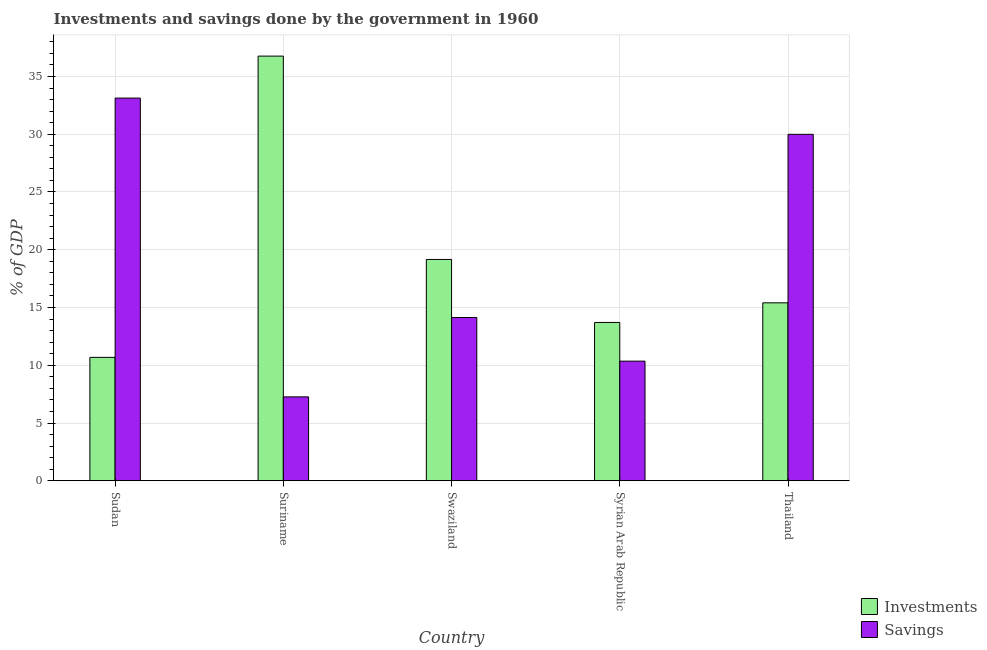How many groups of bars are there?
Provide a short and direct response. 5. Are the number of bars per tick equal to the number of legend labels?
Offer a very short reply. Yes. How many bars are there on the 4th tick from the right?
Offer a very short reply. 2. What is the label of the 4th group of bars from the left?
Your answer should be very brief. Syrian Arab Republic. What is the investments of government in Syrian Arab Republic?
Ensure brevity in your answer.  13.71. Across all countries, what is the maximum savings of government?
Make the answer very short. 33.13. Across all countries, what is the minimum investments of government?
Offer a terse response. 10.68. In which country was the investments of government maximum?
Provide a succinct answer. Suriname. In which country was the savings of government minimum?
Keep it short and to the point. Suriname. What is the total investments of government in the graph?
Offer a very short reply. 95.71. What is the difference between the savings of government in Suriname and that in Thailand?
Your response must be concise. -22.73. What is the difference between the investments of government in Swaziland and the savings of government in Thailand?
Offer a very short reply. -10.83. What is the average investments of government per country?
Your response must be concise. 19.14. What is the difference between the investments of government and savings of government in Syrian Arab Republic?
Make the answer very short. 3.35. What is the ratio of the investments of government in Sudan to that in Swaziland?
Keep it short and to the point. 0.56. Is the difference between the investments of government in Swaziland and Thailand greater than the difference between the savings of government in Swaziland and Thailand?
Keep it short and to the point. Yes. What is the difference between the highest and the second highest investments of government?
Give a very brief answer. 17.6. What is the difference between the highest and the lowest investments of government?
Your response must be concise. 26.08. What does the 2nd bar from the left in Swaziland represents?
Your answer should be compact. Savings. What does the 2nd bar from the right in Thailand represents?
Provide a short and direct response. Investments. What is the difference between two consecutive major ticks on the Y-axis?
Provide a succinct answer. 5. Does the graph contain any zero values?
Provide a short and direct response. No. Does the graph contain grids?
Give a very brief answer. Yes. What is the title of the graph?
Offer a very short reply. Investments and savings done by the government in 1960. Does "Commercial bank branches" appear as one of the legend labels in the graph?
Offer a terse response. No. What is the label or title of the X-axis?
Make the answer very short. Country. What is the label or title of the Y-axis?
Your response must be concise. % of GDP. What is the % of GDP in Investments in Sudan?
Provide a short and direct response. 10.68. What is the % of GDP of Savings in Sudan?
Your answer should be compact. 33.13. What is the % of GDP of Investments in Suriname?
Provide a short and direct response. 36.76. What is the % of GDP in Savings in Suriname?
Your answer should be very brief. 7.26. What is the % of GDP of Investments in Swaziland?
Your answer should be compact. 19.16. What is the % of GDP in Savings in Swaziland?
Offer a very short reply. 14.13. What is the % of GDP in Investments in Syrian Arab Republic?
Your response must be concise. 13.71. What is the % of GDP in Savings in Syrian Arab Republic?
Your response must be concise. 10.36. What is the % of GDP in Investments in Thailand?
Your response must be concise. 15.41. What is the % of GDP of Savings in Thailand?
Your answer should be very brief. 29.99. Across all countries, what is the maximum % of GDP of Investments?
Offer a very short reply. 36.76. Across all countries, what is the maximum % of GDP in Savings?
Make the answer very short. 33.13. Across all countries, what is the minimum % of GDP of Investments?
Keep it short and to the point. 10.68. Across all countries, what is the minimum % of GDP of Savings?
Provide a short and direct response. 7.26. What is the total % of GDP in Investments in the graph?
Make the answer very short. 95.71. What is the total % of GDP in Savings in the graph?
Your response must be concise. 94.87. What is the difference between the % of GDP of Investments in Sudan and that in Suriname?
Offer a very short reply. -26.08. What is the difference between the % of GDP of Savings in Sudan and that in Suriname?
Give a very brief answer. 25.86. What is the difference between the % of GDP in Investments in Sudan and that in Swaziland?
Provide a succinct answer. -8.47. What is the difference between the % of GDP of Savings in Sudan and that in Swaziland?
Make the answer very short. 18.99. What is the difference between the % of GDP of Investments in Sudan and that in Syrian Arab Republic?
Offer a very short reply. -3.02. What is the difference between the % of GDP in Savings in Sudan and that in Syrian Arab Republic?
Offer a very short reply. 22.77. What is the difference between the % of GDP of Investments in Sudan and that in Thailand?
Offer a very short reply. -4.72. What is the difference between the % of GDP of Savings in Sudan and that in Thailand?
Your response must be concise. 3.14. What is the difference between the % of GDP of Investments in Suriname and that in Swaziland?
Provide a succinct answer. 17.6. What is the difference between the % of GDP of Savings in Suriname and that in Swaziland?
Keep it short and to the point. -6.87. What is the difference between the % of GDP in Investments in Suriname and that in Syrian Arab Republic?
Your response must be concise. 23.05. What is the difference between the % of GDP of Savings in Suriname and that in Syrian Arab Republic?
Your answer should be very brief. -3.09. What is the difference between the % of GDP of Investments in Suriname and that in Thailand?
Provide a succinct answer. 21.36. What is the difference between the % of GDP of Savings in Suriname and that in Thailand?
Provide a short and direct response. -22.73. What is the difference between the % of GDP in Investments in Swaziland and that in Syrian Arab Republic?
Keep it short and to the point. 5.45. What is the difference between the % of GDP in Savings in Swaziland and that in Syrian Arab Republic?
Keep it short and to the point. 3.78. What is the difference between the % of GDP in Investments in Swaziland and that in Thailand?
Offer a terse response. 3.75. What is the difference between the % of GDP in Savings in Swaziland and that in Thailand?
Provide a succinct answer. -15.86. What is the difference between the % of GDP of Investments in Syrian Arab Republic and that in Thailand?
Keep it short and to the point. -1.7. What is the difference between the % of GDP in Savings in Syrian Arab Republic and that in Thailand?
Give a very brief answer. -19.63. What is the difference between the % of GDP of Investments in Sudan and the % of GDP of Savings in Suriname?
Provide a succinct answer. 3.42. What is the difference between the % of GDP of Investments in Sudan and the % of GDP of Savings in Swaziland?
Make the answer very short. -3.45. What is the difference between the % of GDP of Investments in Sudan and the % of GDP of Savings in Syrian Arab Republic?
Give a very brief answer. 0.33. What is the difference between the % of GDP in Investments in Sudan and the % of GDP in Savings in Thailand?
Offer a very short reply. -19.31. What is the difference between the % of GDP of Investments in Suriname and the % of GDP of Savings in Swaziland?
Your answer should be very brief. 22.63. What is the difference between the % of GDP in Investments in Suriname and the % of GDP in Savings in Syrian Arab Republic?
Give a very brief answer. 26.4. What is the difference between the % of GDP in Investments in Suriname and the % of GDP in Savings in Thailand?
Provide a succinct answer. 6.77. What is the difference between the % of GDP of Investments in Swaziland and the % of GDP of Savings in Syrian Arab Republic?
Keep it short and to the point. 8.8. What is the difference between the % of GDP of Investments in Swaziland and the % of GDP of Savings in Thailand?
Provide a succinct answer. -10.83. What is the difference between the % of GDP in Investments in Syrian Arab Republic and the % of GDP in Savings in Thailand?
Keep it short and to the point. -16.28. What is the average % of GDP in Investments per country?
Your answer should be compact. 19.14. What is the average % of GDP in Savings per country?
Give a very brief answer. 18.97. What is the difference between the % of GDP in Investments and % of GDP in Savings in Sudan?
Your response must be concise. -22.44. What is the difference between the % of GDP in Investments and % of GDP in Savings in Suriname?
Offer a terse response. 29.5. What is the difference between the % of GDP of Investments and % of GDP of Savings in Swaziland?
Keep it short and to the point. 5.02. What is the difference between the % of GDP in Investments and % of GDP in Savings in Syrian Arab Republic?
Offer a very short reply. 3.35. What is the difference between the % of GDP of Investments and % of GDP of Savings in Thailand?
Give a very brief answer. -14.58. What is the ratio of the % of GDP in Investments in Sudan to that in Suriname?
Make the answer very short. 0.29. What is the ratio of the % of GDP of Savings in Sudan to that in Suriname?
Provide a short and direct response. 4.56. What is the ratio of the % of GDP in Investments in Sudan to that in Swaziland?
Your answer should be very brief. 0.56. What is the ratio of the % of GDP in Savings in Sudan to that in Swaziland?
Make the answer very short. 2.34. What is the ratio of the % of GDP in Investments in Sudan to that in Syrian Arab Republic?
Keep it short and to the point. 0.78. What is the ratio of the % of GDP of Savings in Sudan to that in Syrian Arab Republic?
Your answer should be very brief. 3.2. What is the ratio of the % of GDP of Investments in Sudan to that in Thailand?
Provide a short and direct response. 0.69. What is the ratio of the % of GDP in Savings in Sudan to that in Thailand?
Make the answer very short. 1.1. What is the ratio of the % of GDP of Investments in Suriname to that in Swaziland?
Provide a succinct answer. 1.92. What is the ratio of the % of GDP in Savings in Suriname to that in Swaziland?
Provide a succinct answer. 0.51. What is the ratio of the % of GDP in Investments in Suriname to that in Syrian Arab Republic?
Make the answer very short. 2.68. What is the ratio of the % of GDP in Savings in Suriname to that in Syrian Arab Republic?
Your response must be concise. 0.7. What is the ratio of the % of GDP of Investments in Suriname to that in Thailand?
Your response must be concise. 2.39. What is the ratio of the % of GDP of Savings in Suriname to that in Thailand?
Your response must be concise. 0.24. What is the ratio of the % of GDP in Investments in Swaziland to that in Syrian Arab Republic?
Give a very brief answer. 1.4. What is the ratio of the % of GDP of Savings in Swaziland to that in Syrian Arab Republic?
Ensure brevity in your answer.  1.36. What is the ratio of the % of GDP of Investments in Swaziland to that in Thailand?
Your response must be concise. 1.24. What is the ratio of the % of GDP of Savings in Swaziland to that in Thailand?
Keep it short and to the point. 0.47. What is the ratio of the % of GDP in Investments in Syrian Arab Republic to that in Thailand?
Make the answer very short. 0.89. What is the ratio of the % of GDP of Savings in Syrian Arab Republic to that in Thailand?
Offer a terse response. 0.35. What is the difference between the highest and the second highest % of GDP of Investments?
Offer a terse response. 17.6. What is the difference between the highest and the second highest % of GDP in Savings?
Your answer should be very brief. 3.14. What is the difference between the highest and the lowest % of GDP in Investments?
Offer a very short reply. 26.08. What is the difference between the highest and the lowest % of GDP in Savings?
Your answer should be compact. 25.86. 